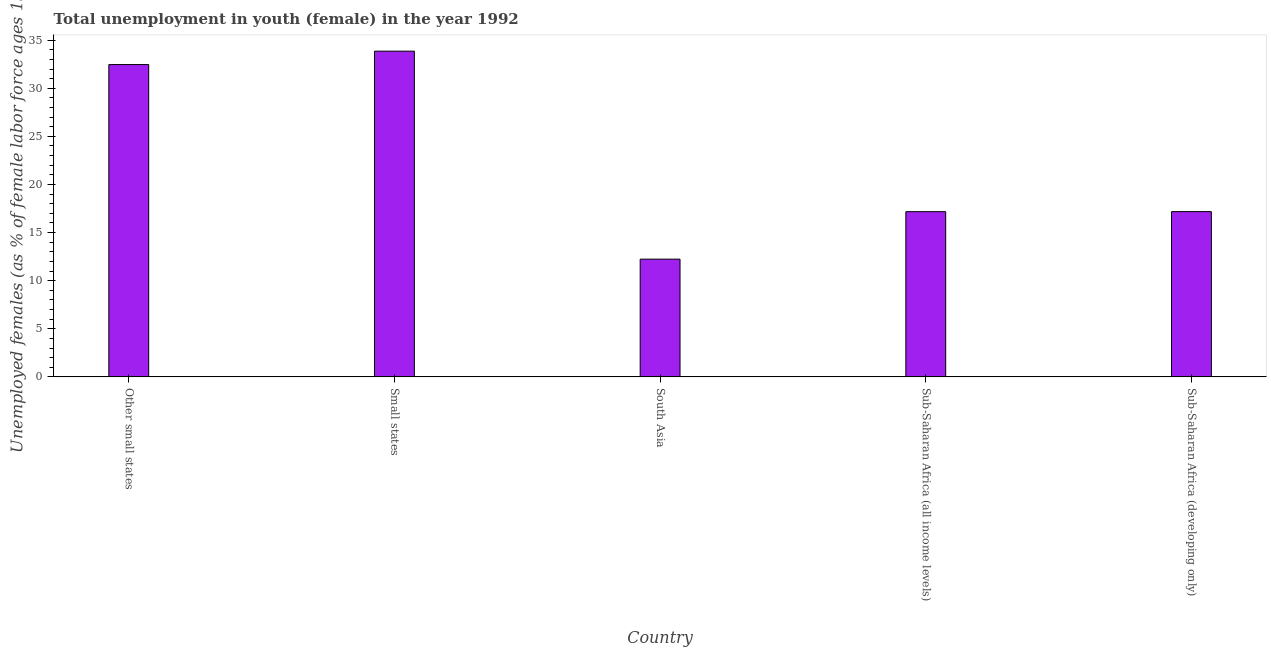Does the graph contain any zero values?
Keep it short and to the point. No. Does the graph contain grids?
Provide a succinct answer. No. What is the title of the graph?
Keep it short and to the point. Total unemployment in youth (female) in the year 1992. What is the label or title of the Y-axis?
Your answer should be compact. Unemployed females (as % of female labor force ages 15-24). What is the unemployed female youth population in Small states?
Provide a short and direct response. 33.85. Across all countries, what is the maximum unemployed female youth population?
Provide a short and direct response. 33.85. Across all countries, what is the minimum unemployed female youth population?
Ensure brevity in your answer.  12.24. In which country was the unemployed female youth population maximum?
Make the answer very short. Small states. What is the sum of the unemployed female youth population?
Provide a succinct answer. 112.9. What is the difference between the unemployed female youth population in Sub-Saharan Africa (all income levels) and Sub-Saharan Africa (developing only)?
Give a very brief answer. -0.01. What is the average unemployed female youth population per country?
Make the answer very short. 22.58. What is the median unemployed female youth population?
Ensure brevity in your answer.  17.18. What is the ratio of the unemployed female youth population in South Asia to that in Sub-Saharan Africa (developing only)?
Your answer should be very brief. 0.71. Is the unemployed female youth population in Other small states less than that in Small states?
Make the answer very short. Yes. What is the difference between the highest and the second highest unemployed female youth population?
Provide a short and direct response. 1.39. What is the difference between the highest and the lowest unemployed female youth population?
Offer a very short reply. 21.62. What is the difference between two consecutive major ticks on the Y-axis?
Your answer should be very brief. 5. Are the values on the major ticks of Y-axis written in scientific E-notation?
Provide a short and direct response. No. What is the Unemployed females (as % of female labor force ages 15-24) of Other small states?
Offer a terse response. 32.46. What is the Unemployed females (as % of female labor force ages 15-24) in Small states?
Provide a short and direct response. 33.85. What is the Unemployed females (as % of female labor force ages 15-24) of South Asia?
Keep it short and to the point. 12.24. What is the Unemployed females (as % of female labor force ages 15-24) of Sub-Saharan Africa (all income levels)?
Offer a terse response. 17.17. What is the Unemployed females (as % of female labor force ages 15-24) of Sub-Saharan Africa (developing only)?
Your answer should be compact. 17.18. What is the difference between the Unemployed females (as % of female labor force ages 15-24) in Other small states and Small states?
Your response must be concise. -1.39. What is the difference between the Unemployed females (as % of female labor force ages 15-24) in Other small states and South Asia?
Provide a succinct answer. 20.22. What is the difference between the Unemployed females (as % of female labor force ages 15-24) in Other small states and Sub-Saharan Africa (all income levels)?
Your answer should be very brief. 15.29. What is the difference between the Unemployed females (as % of female labor force ages 15-24) in Other small states and Sub-Saharan Africa (developing only)?
Offer a terse response. 15.28. What is the difference between the Unemployed females (as % of female labor force ages 15-24) in Small states and South Asia?
Offer a very short reply. 21.62. What is the difference between the Unemployed females (as % of female labor force ages 15-24) in Small states and Sub-Saharan Africa (all income levels)?
Your answer should be very brief. 16.68. What is the difference between the Unemployed females (as % of female labor force ages 15-24) in Small states and Sub-Saharan Africa (developing only)?
Give a very brief answer. 16.68. What is the difference between the Unemployed females (as % of female labor force ages 15-24) in South Asia and Sub-Saharan Africa (all income levels)?
Keep it short and to the point. -4.93. What is the difference between the Unemployed females (as % of female labor force ages 15-24) in South Asia and Sub-Saharan Africa (developing only)?
Your answer should be very brief. -4.94. What is the difference between the Unemployed females (as % of female labor force ages 15-24) in Sub-Saharan Africa (all income levels) and Sub-Saharan Africa (developing only)?
Ensure brevity in your answer.  -0.01. What is the ratio of the Unemployed females (as % of female labor force ages 15-24) in Other small states to that in South Asia?
Provide a short and direct response. 2.65. What is the ratio of the Unemployed females (as % of female labor force ages 15-24) in Other small states to that in Sub-Saharan Africa (all income levels)?
Your response must be concise. 1.89. What is the ratio of the Unemployed females (as % of female labor force ages 15-24) in Other small states to that in Sub-Saharan Africa (developing only)?
Your answer should be compact. 1.89. What is the ratio of the Unemployed females (as % of female labor force ages 15-24) in Small states to that in South Asia?
Offer a terse response. 2.77. What is the ratio of the Unemployed females (as % of female labor force ages 15-24) in Small states to that in Sub-Saharan Africa (all income levels)?
Offer a terse response. 1.97. What is the ratio of the Unemployed females (as % of female labor force ages 15-24) in Small states to that in Sub-Saharan Africa (developing only)?
Make the answer very short. 1.97. What is the ratio of the Unemployed females (as % of female labor force ages 15-24) in South Asia to that in Sub-Saharan Africa (all income levels)?
Keep it short and to the point. 0.71. What is the ratio of the Unemployed females (as % of female labor force ages 15-24) in South Asia to that in Sub-Saharan Africa (developing only)?
Provide a short and direct response. 0.71. What is the ratio of the Unemployed females (as % of female labor force ages 15-24) in Sub-Saharan Africa (all income levels) to that in Sub-Saharan Africa (developing only)?
Your response must be concise. 1. 